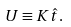Convert formula to latex. <formula><loc_0><loc_0><loc_500><loc_500>U \equiv K \hat { t } .</formula> 